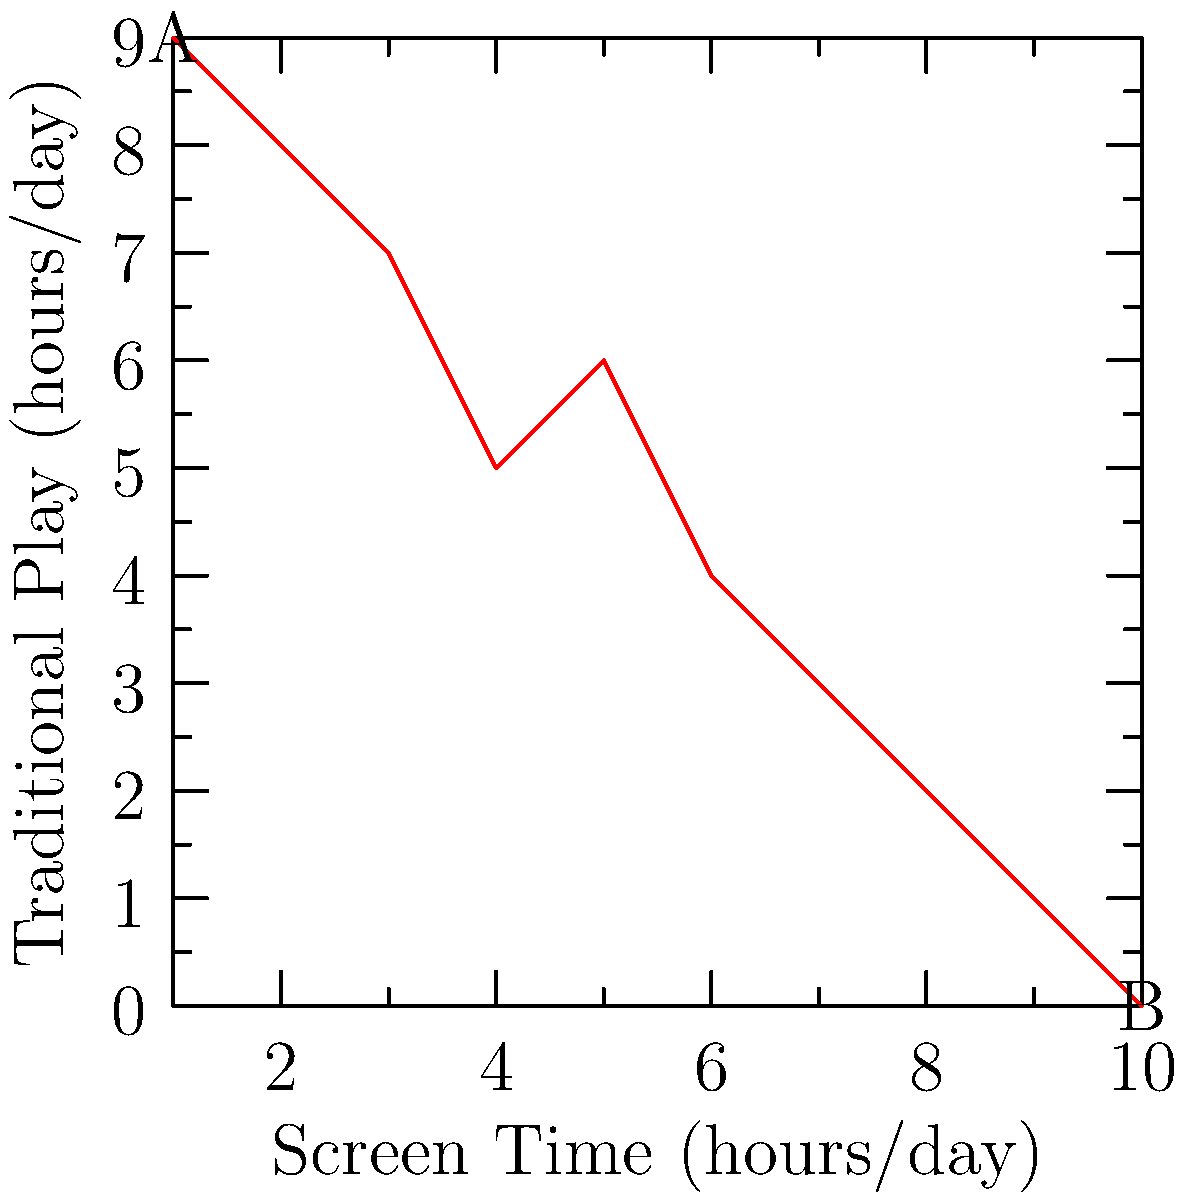As a tabletop game enthusiast and toy store owner, you're concerned about the impact of screen time on traditional play activities. The scatter plot above shows the relationship between daily screen time and time spent on traditional play for a group of children. What type of correlation does this data suggest, and how might this information influence your business strategy? 1. Analyze the scatter plot:
   - The x-axis represents screen time (hours/day)
   - The y-axis represents time spent on traditional play (hours/day)
   - Points are distributed from A (1,9) to B (10,0)

2. Observe the trend:
   - As screen time increases, time spent on traditional play decreases
   - The points form a roughly linear pattern from top-left to bottom-right

3. Identify the correlation:
   - This pattern indicates a negative (inverse) correlation
   - As one variable increases, the other decreases

4. Strength of correlation:
   - The points closely follow a straight line
   - This suggests a strong negative correlation

5. Business strategy implications:
   - The data confirms concerns about screen time's impact on traditional play
   - This could justify efforts to promote screen-free activities
   - Consider marketing strategies emphasizing the benefits of traditional play
   - Potentially develop products that combine traditional play with limited screen interaction

6. Limitations to consider:
   - Correlation does not imply causation
   - Other factors may influence this relationship
   - The sample size and demographic are not specified
Answer: Strong negative correlation; adapt business to promote screen-free play and hybrid products 